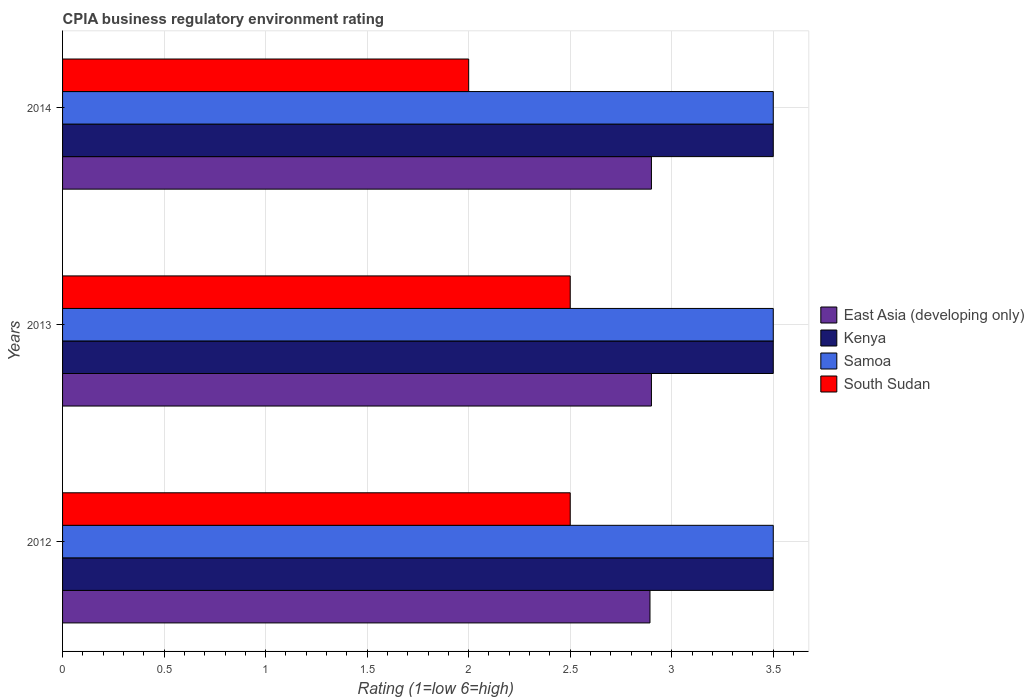How many different coloured bars are there?
Your answer should be very brief. 4. How many groups of bars are there?
Give a very brief answer. 3. Are the number of bars per tick equal to the number of legend labels?
Your response must be concise. Yes. Are the number of bars on each tick of the Y-axis equal?
Ensure brevity in your answer.  Yes. How many bars are there on the 1st tick from the top?
Give a very brief answer. 4. What is the CPIA rating in East Asia (developing only) in 2012?
Give a very brief answer. 2.89. Across all years, what is the minimum CPIA rating in South Sudan?
Your response must be concise. 2. In which year was the CPIA rating in Samoa maximum?
Make the answer very short. 2012. What is the difference between the CPIA rating in South Sudan in 2012 and that in 2013?
Offer a very short reply. 0. What is the difference between the CPIA rating in Kenya in 2013 and the CPIA rating in South Sudan in 2012?
Make the answer very short. 1. What is the average CPIA rating in South Sudan per year?
Make the answer very short. 2.33. What is the ratio of the CPIA rating in Samoa in 2013 to that in 2014?
Keep it short and to the point. 1. Is the CPIA rating in Samoa in 2012 less than that in 2014?
Offer a terse response. No. What is the difference between the highest and the second highest CPIA rating in Kenya?
Make the answer very short. 0. What is the difference between the highest and the lowest CPIA rating in East Asia (developing only)?
Ensure brevity in your answer.  0.01. In how many years, is the CPIA rating in Kenya greater than the average CPIA rating in Kenya taken over all years?
Make the answer very short. 0. What does the 2nd bar from the top in 2012 represents?
Give a very brief answer. Samoa. What does the 1st bar from the bottom in 2013 represents?
Offer a very short reply. East Asia (developing only). How many bars are there?
Give a very brief answer. 12. How many years are there in the graph?
Provide a short and direct response. 3. Does the graph contain grids?
Your answer should be compact. Yes. Where does the legend appear in the graph?
Offer a terse response. Center right. What is the title of the graph?
Offer a terse response. CPIA business regulatory environment rating. What is the label or title of the Y-axis?
Ensure brevity in your answer.  Years. What is the Rating (1=low 6=high) in East Asia (developing only) in 2012?
Provide a short and direct response. 2.89. What is the Rating (1=low 6=high) in Samoa in 2012?
Provide a succinct answer. 3.5. What is the Rating (1=low 6=high) in Samoa in 2013?
Offer a terse response. 3.5. What is the Rating (1=low 6=high) in Samoa in 2014?
Keep it short and to the point. 3.5. What is the Rating (1=low 6=high) in South Sudan in 2014?
Keep it short and to the point. 2. Across all years, what is the maximum Rating (1=low 6=high) of Kenya?
Your answer should be very brief. 3.5. Across all years, what is the maximum Rating (1=low 6=high) of South Sudan?
Keep it short and to the point. 2.5. Across all years, what is the minimum Rating (1=low 6=high) of East Asia (developing only)?
Provide a short and direct response. 2.89. Across all years, what is the minimum Rating (1=low 6=high) in Kenya?
Provide a succinct answer. 3.5. Across all years, what is the minimum Rating (1=low 6=high) of South Sudan?
Your answer should be compact. 2. What is the total Rating (1=low 6=high) in East Asia (developing only) in the graph?
Your answer should be compact. 8.69. What is the total Rating (1=low 6=high) of Kenya in the graph?
Provide a succinct answer. 10.5. What is the total Rating (1=low 6=high) in South Sudan in the graph?
Give a very brief answer. 7. What is the difference between the Rating (1=low 6=high) in East Asia (developing only) in 2012 and that in 2013?
Your answer should be compact. -0.01. What is the difference between the Rating (1=low 6=high) of Kenya in 2012 and that in 2013?
Your response must be concise. 0. What is the difference between the Rating (1=low 6=high) in South Sudan in 2012 and that in 2013?
Your response must be concise. 0. What is the difference between the Rating (1=low 6=high) of East Asia (developing only) in 2012 and that in 2014?
Give a very brief answer. -0.01. What is the difference between the Rating (1=low 6=high) of Samoa in 2012 and that in 2014?
Offer a very short reply. 0. What is the difference between the Rating (1=low 6=high) in South Sudan in 2012 and that in 2014?
Provide a succinct answer. 0.5. What is the difference between the Rating (1=low 6=high) of East Asia (developing only) in 2013 and that in 2014?
Offer a terse response. 0. What is the difference between the Rating (1=low 6=high) of East Asia (developing only) in 2012 and the Rating (1=low 6=high) of Kenya in 2013?
Offer a terse response. -0.61. What is the difference between the Rating (1=low 6=high) of East Asia (developing only) in 2012 and the Rating (1=low 6=high) of Samoa in 2013?
Provide a short and direct response. -0.61. What is the difference between the Rating (1=low 6=high) of East Asia (developing only) in 2012 and the Rating (1=low 6=high) of South Sudan in 2013?
Provide a succinct answer. 0.39. What is the difference between the Rating (1=low 6=high) in Kenya in 2012 and the Rating (1=low 6=high) in South Sudan in 2013?
Provide a succinct answer. 1. What is the difference between the Rating (1=low 6=high) in East Asia (developing only) in 2012 and the Rating (1=low 6=high) in Kenya in 2014?
Keep it short and to the point. -0.61. What is the difference between the Rating (1=low 6=high) of East Asia (developing only) in 2012 and the Rating (1=low 6=high) of Samoa in 2014?
Your response must be concise. -0.61. What is the difference between the Rating (1=low 6=high) in East Asia (developing only) in 2012 and the Rating (1=low 6=high) in South Sudan in 2014?
Your answer should be very brief. 0.89. What is the difference between the Rating (1=low 6=high) in Kenya in 2012 and the Rating (1=low 6=high) in South Sudan in 2014?
Give a very brief answer. 1.5. What is the difference between the Rating (1=low 6=high) of East Asia (developing only) in 2013 and the Rating (1=low 6=high) of Kenya in 2014?
Ensure brevity in your answer.  -0.6. What is the difference between the Rating (1=low 6=high) of East Asia (developing only) in 2013 and the Rating (1=low 6=high) of Samoa in 2014?
Your response must be concise. -0.6. What is the difference between the Rating (1=low 6=high) in East Asia (developing only) in 2013 and the Rating (1=low 6=high) in South Sudan in 2014?
Provide a short and direct response. 0.9. What is the difference between the Rating (1=low 6=high) of Kenya in 2013 and the Rating (1=low 6=high) of Samoa in 2014?
Provide a short and direct response. 0. What is the difference between the Rating (1=low 6=high) in Samoa in 2013 and the Rating (1=low 6=high) in South Sudan in 2014?
Give a very brief answer. 1.5. What is the average Rating (1=low 6=high) of East Asia (developing only) per year?
Provide a short and direct response. 2.9. What is the average Rating (1=low 6=high) in South Sudan per year?
Your answer should be very brief. 2.33. In the year 2012, what is the difference between the Rating (1=low 6=high) in East Asia (developing only) and Rating (1=low 6=high) in Kenya?
Ensure brevity in your answer.  -0.61. In the year 2012, what is the difference between the Rating (1=low 6=high) in East Asia (developing only) and Rating (1=low 6=high) in Samoa?
Give a very brief answer. -0.61. In the year 2012, what is the difference between the Rating (1=low 6=high) of East Asia (developing only) and Rating (1=low 6=high) of South Sudan?
Offer a terse response. 0.39. In the year 2013, what is the difference between the Rating (1=low 6=high) of East Asia (developing only) and Rating (1=low 6=high) of Samoa?
Your response must be concise. -0.6. In the year 2013, what is the difference between the Rating (1=low 6=high) of Kenya and Rating (1=low 6=high) of Samoa?
Provide a succinct answer. 0. In the year 2014, what is the difference between the Rating (1=low 6=high) in East Asia (developing only) and Rating (1=low 6=high) in Samoa?
Your answer should be compact. -0.6. In the year 2014, what is the difference between the Rating (1=low 6=high) of East Asia (developing only) and Rating (1=low 6=high) of South Sudan?
Make the answer very short. 0.9. In the year 2014, what is the difference between the Rating (1=low 6=high) of Kenya and Rating (1=low 6=high) of South Sudan?
Provide a succinct answer. 1.5. In the year 2014, what is the difference between the Rating (1=low 6=high) of Samoa and Rating (1=low 6=high) of South Sudan?
Your response must be concise. 1.5. What is the ratio of the Rating (1=low 6=high) of Kenya in 2012 to that in 2013?
Keep it short and to the point. 1. What is the ratio of the Rating (1=low 6=high) of East Asia (developing only) in 2012 to that in 2014?
Offer a very short reply. 1. What is the ratio of the Rating (1=low 6=high) in Kenya in 2012 to that in 2014?
Ensure brevity in your answer.  1. What is the ratio of the Rating (1=low 6=high) of Samoa in 2012 to that in 2014?
Provide a succinct answer. 1. What is the difference between the highest and the lowest Rating (1=low 6=high) of East Asia (developing only)?
Ensure brevity in your answer.  0.01. What is the difference between the highest and the lowest Rating (1=low 6=high) of Samoa?
Your answer should be very brief. 0. What is the difference between the highest and the lowest Rating (1=low 6=high) in South Sudan?
Provide a short and direct response. 0.5. 